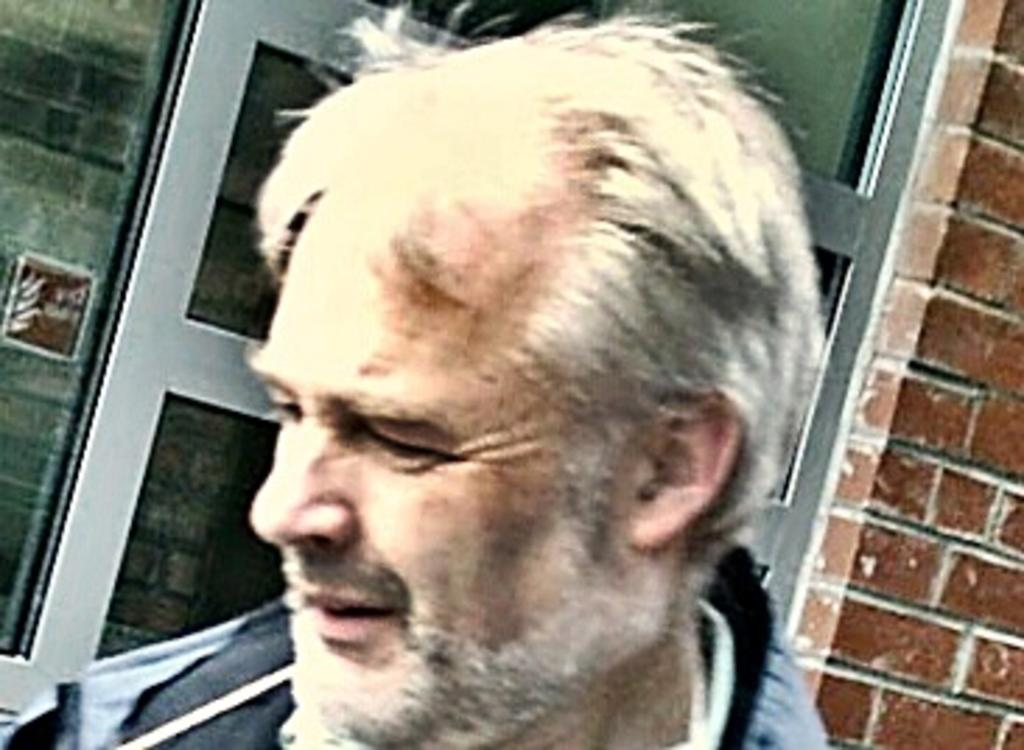What is the person in the image wearing? The person is wearing a grey and ash color dress. What can be seen in the background of the image? There is a window and a brown color brick wall visible in the background. Where is the faucet located in the image? There is no faucet present in the image. What type of patch is sewn onto the dress in the image? There is no patch visible on the dress in the image. 